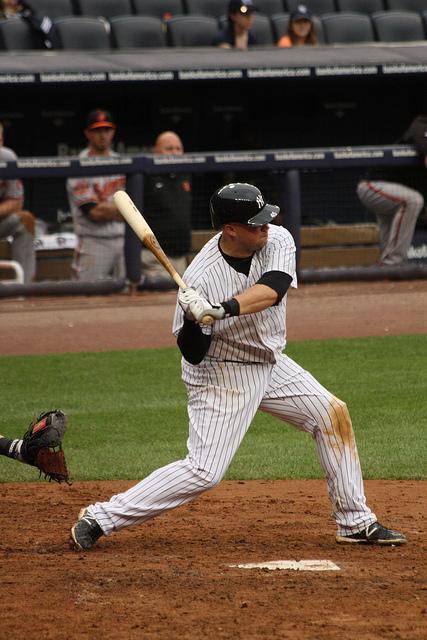How many people are there?
Give a very brief answer. 6. How many benches are there?
Give a very brief answer. 1. How many ovens are there?
Give a very brief answer. 0. 